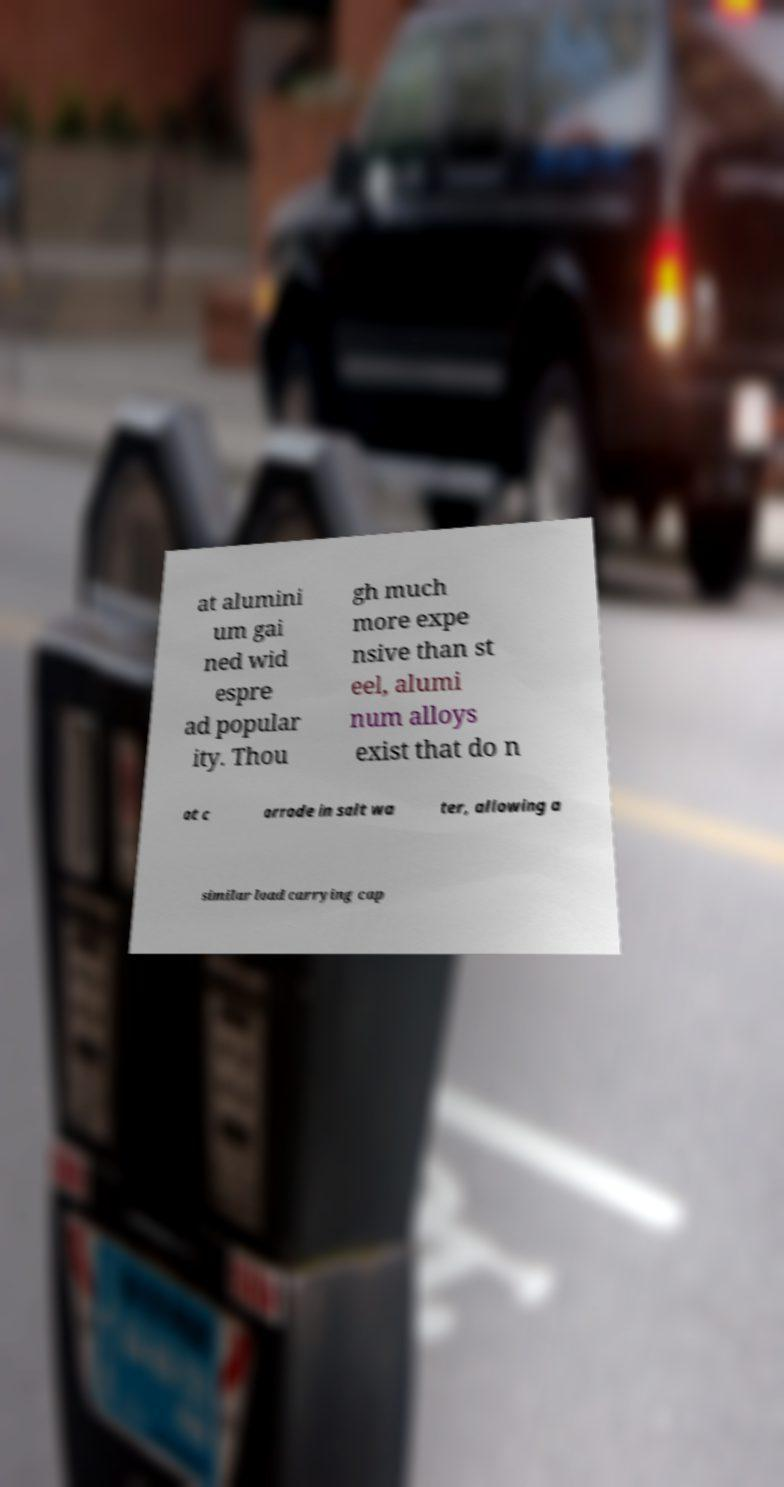Can you read and provide the text displayed in the image?This photo seems to have some interesting text. Can you extract and type it out for me? at alumini um gai ned wid espre ad popular ity. Thou gh much more expe nsive than st eel, alumi num alloys exist that do n ot c orrode in salt wa ter, allowing a similar load carrying cap 